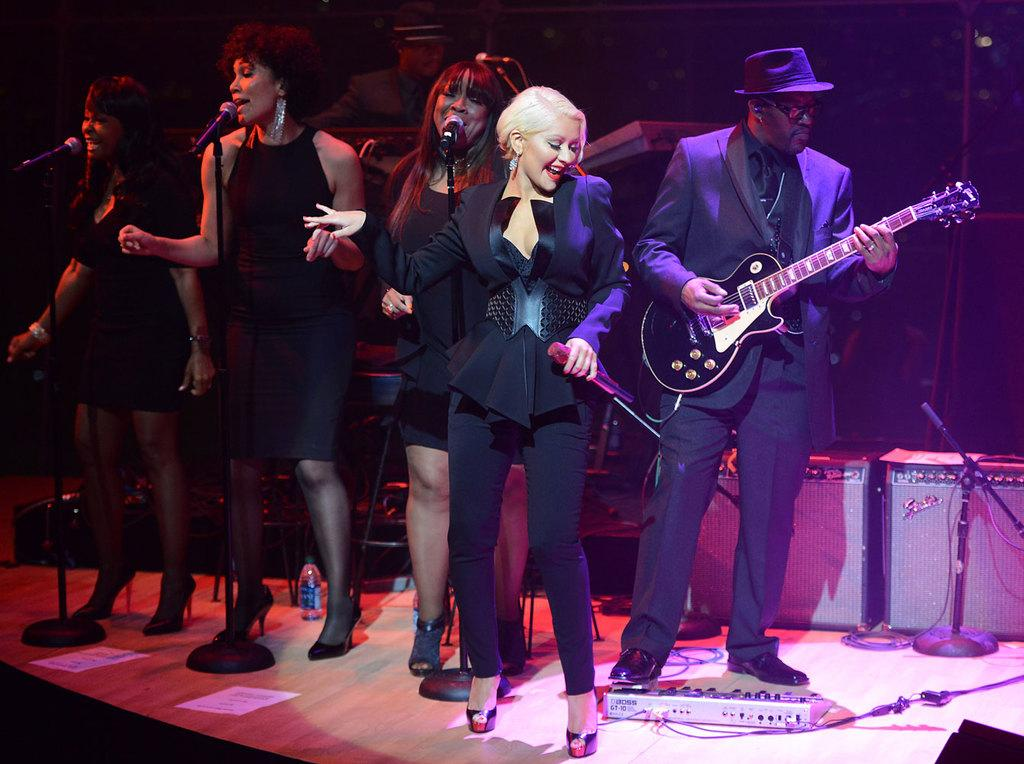What is happening in the image? There are people standing on a stage in the image. What objects are being held by the people on the stage? A man is holding a guitar in his hand, and a woman is holding a microphone in her hand. How many cents are represented by the dime on the stage in the image? There is no dime present on the stage in the image. 